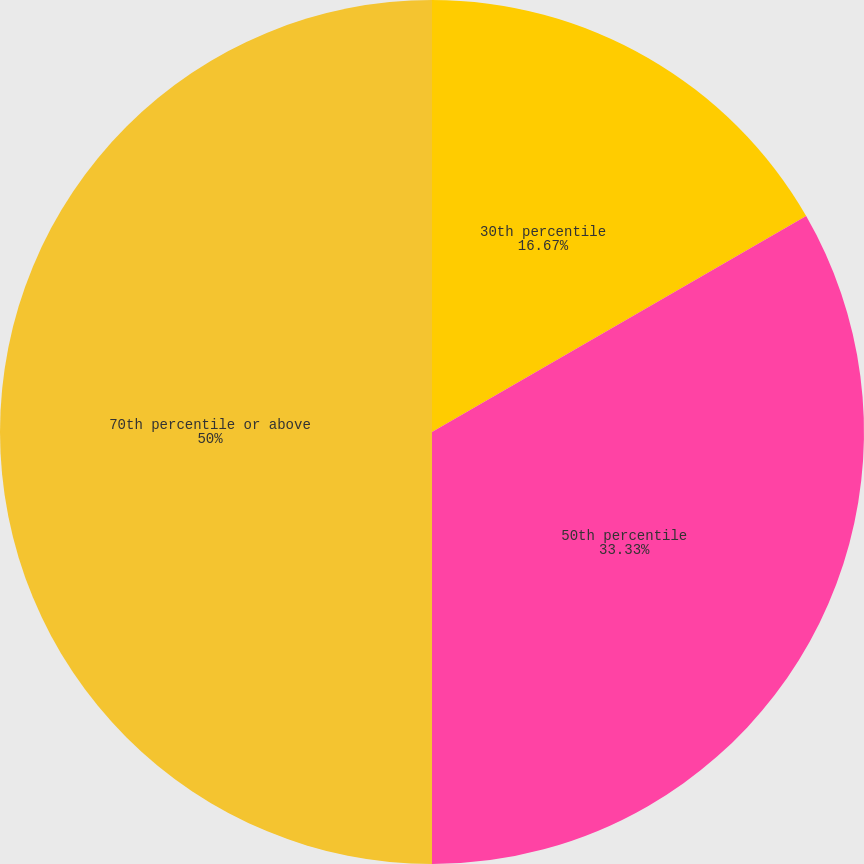Convert chart. <chart><loc_0><loc_0><loc_500><loc_500><pie_chart><fcel>30th percentile<fcel>50th percentile<fcel>70th percentile or above<nl><fcel>16.67%<fcel>33.33%<fcel>50.0%<nl></chart> 